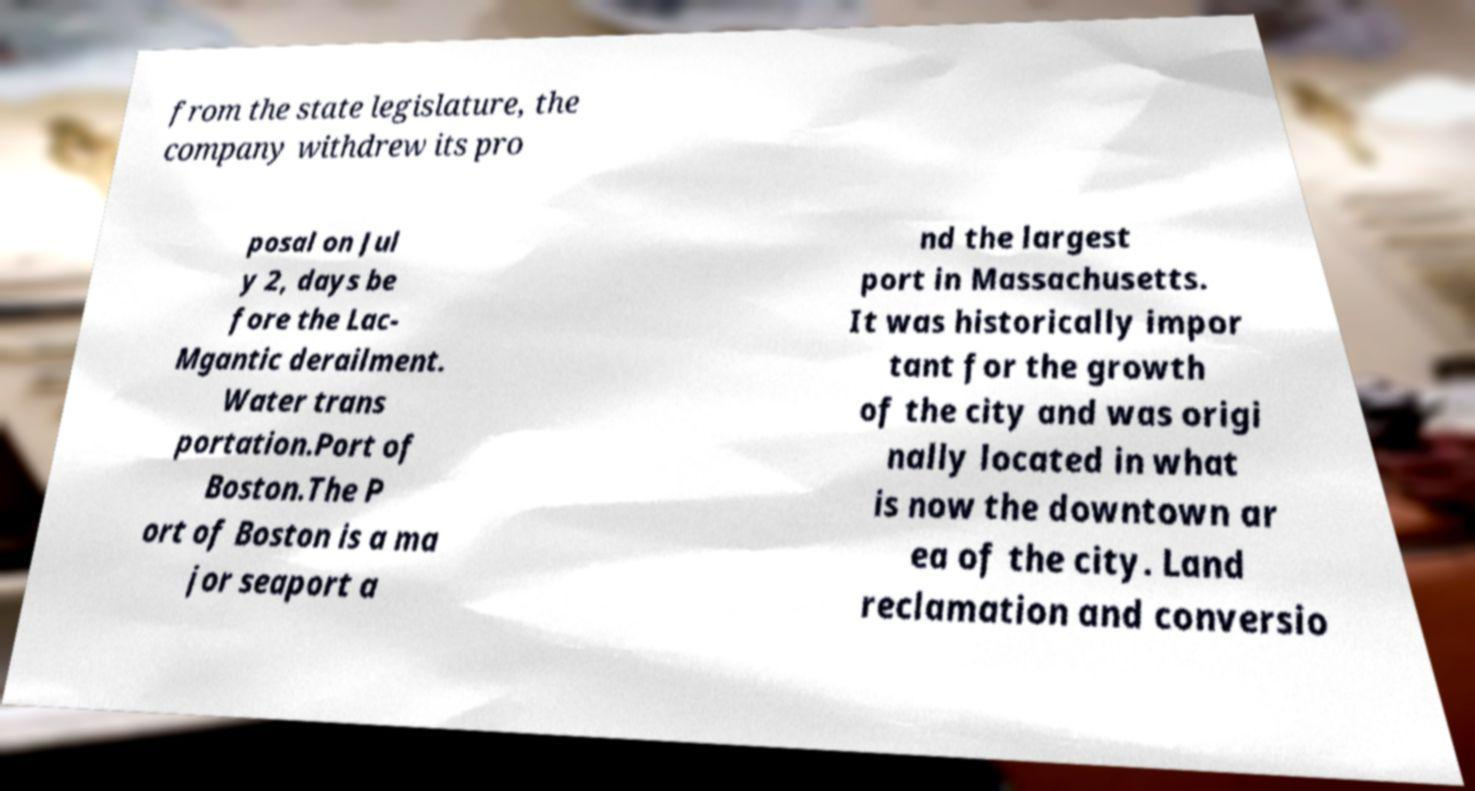Please read and relay the text visible in this image. What does it say? from the state legislature, the company withdrew its pro posal on Jul y 2, days be fore the Lac- Mgantic derailment. Water trans portation.Port of Boston.The P ort of Boston is a ma jor seaport a nd the largest port in Massachusetts. It was historically impor tant for the growth of the city and was origi nally located in what is now the downtown ar ea of the city. Land reclamation and conversio 